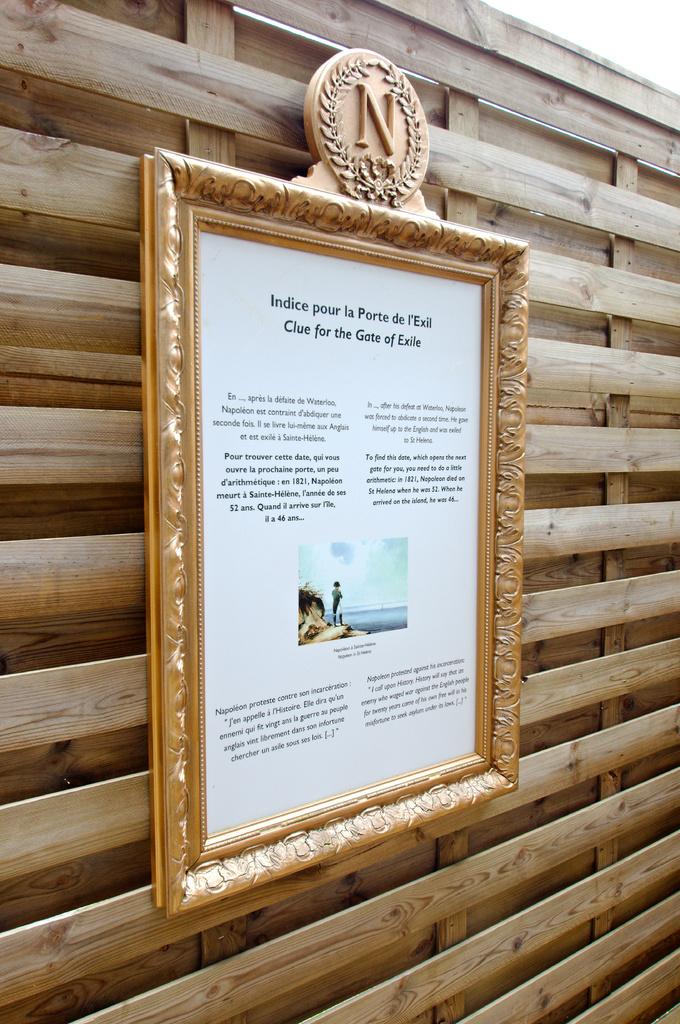What letter is at the top of the sign?
Your answer should be compact. N. What is the first four words on this sign?
Your answer should be very brief. Indice pour la porte. 